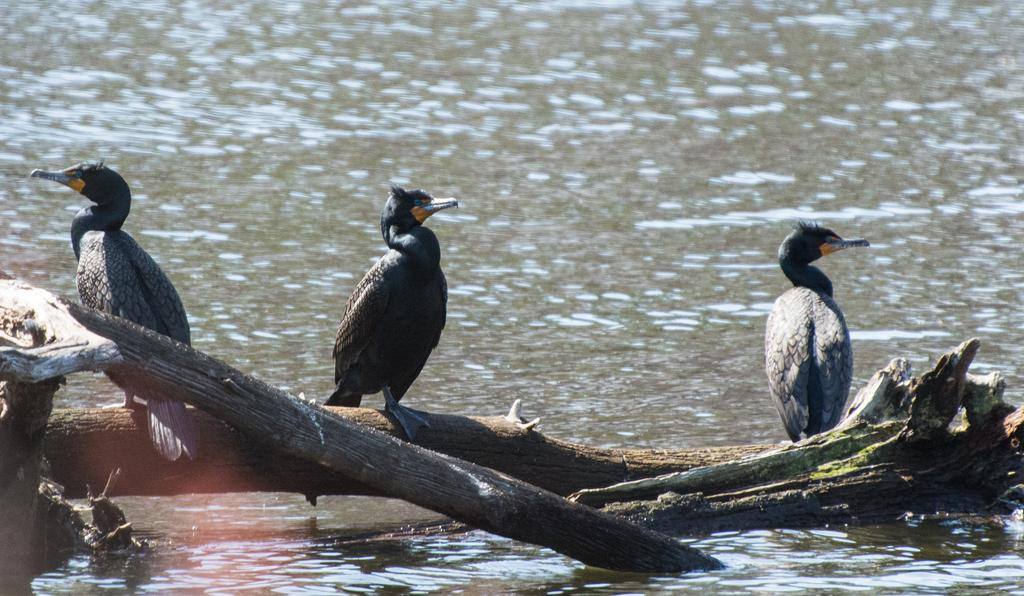How many birds are present in the image? There are three birds in the image. What are the birds standing on? The birds are standing on wooden logs. What is the surrounding environment like for the birds? There is a water surface around the wooden logs. What type of tail does the judge have in the image? There is no judge present in the image, and therefore no tail to describe. 